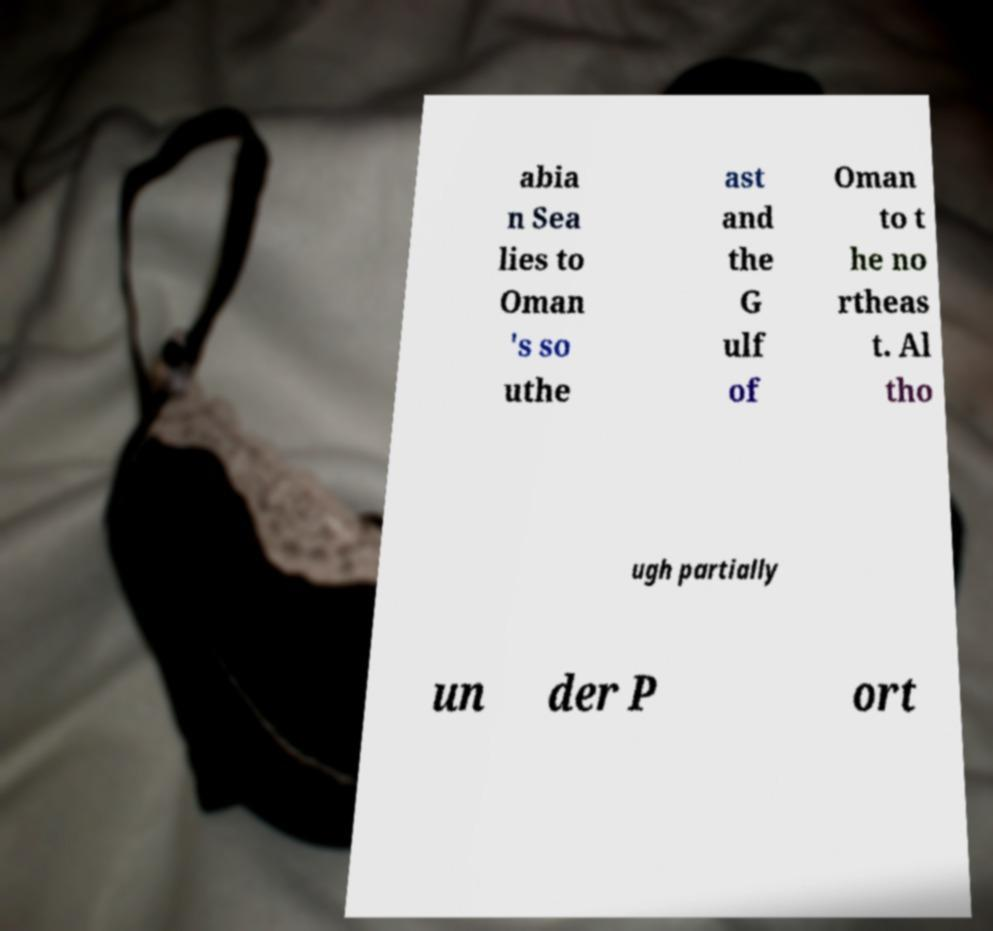For documentation purposes, I need the text within this image transcribed. Could you provide that? abia n Sea lies to Oman 's so uthe ast and the G ulf of Oman to t he no rtheas t. Al tho ugh partially un der P ort 